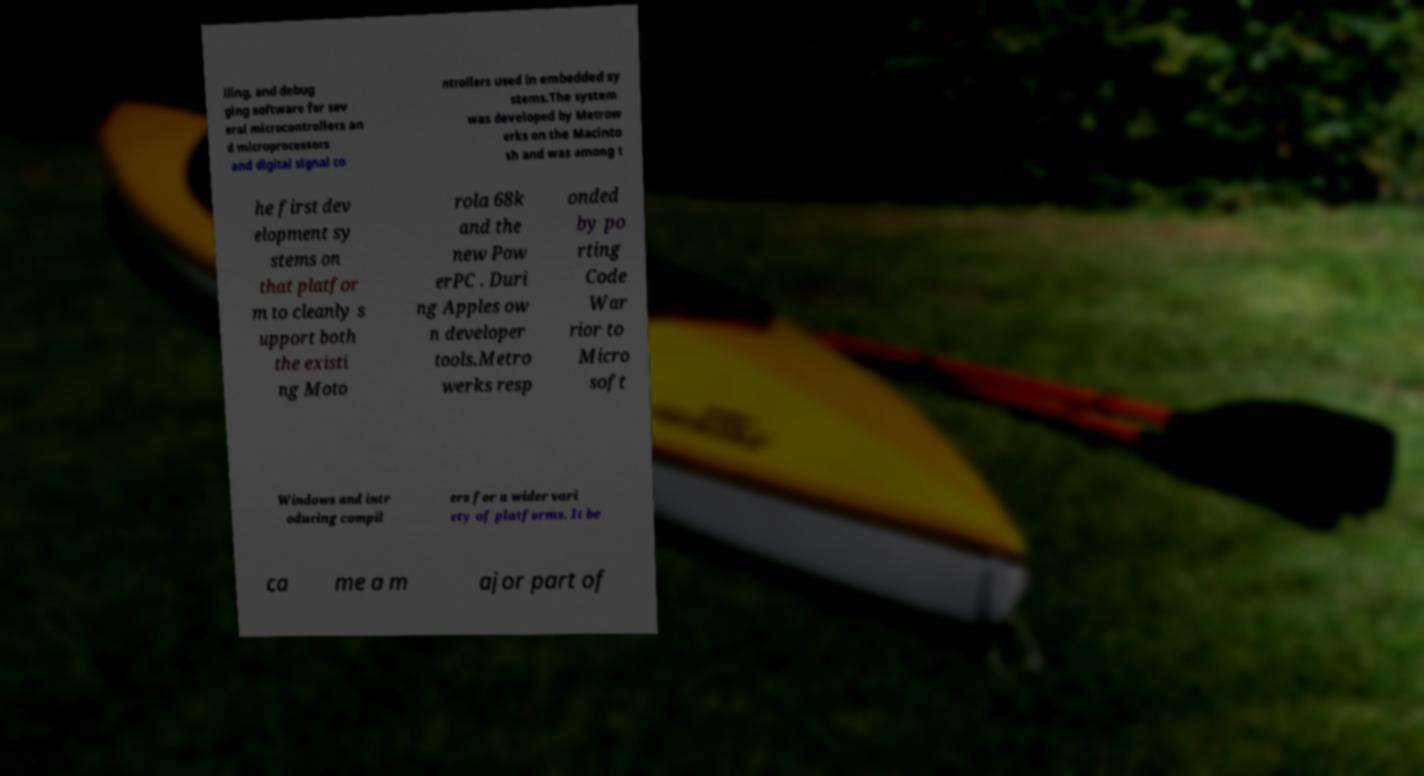What messages or text are displayed in this image? I need them in a readable, typed format. iling, and debug ging software for sev eral microcontrollers an d microprocessors and digital signal co ntrollers used in embedded sy stems.The system was developed by Metrow erks on the Macinto sh and was among t he first dev elopment sy stems on that platfor m to cleanly s upport both the existi ng Moto rola 68k and the new Pow erPC . Duri ng Apples ow n developer tools.Metro werks resp onded by po rting Code War rior to Micro soft Windows and intr oducing compil ers for a wider vari ety of platforms. It be ca me a m ajor part of 